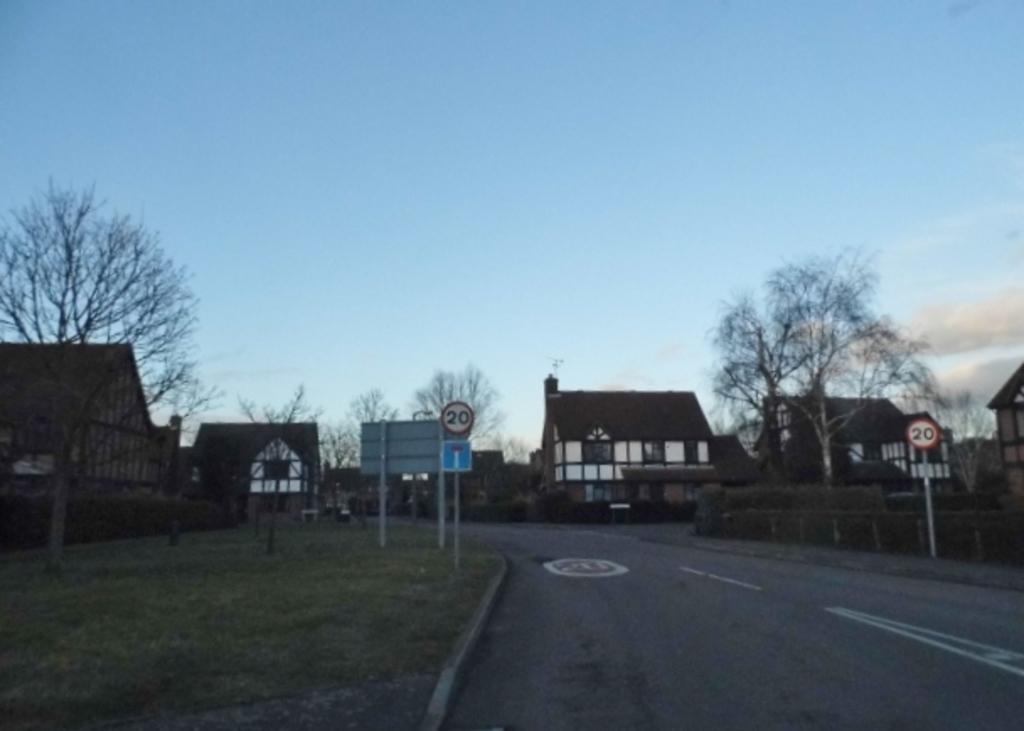Describe this image in one or two sentences. In this image we can see houses, trees, sign boards, also we can see the grass, and the sky. 